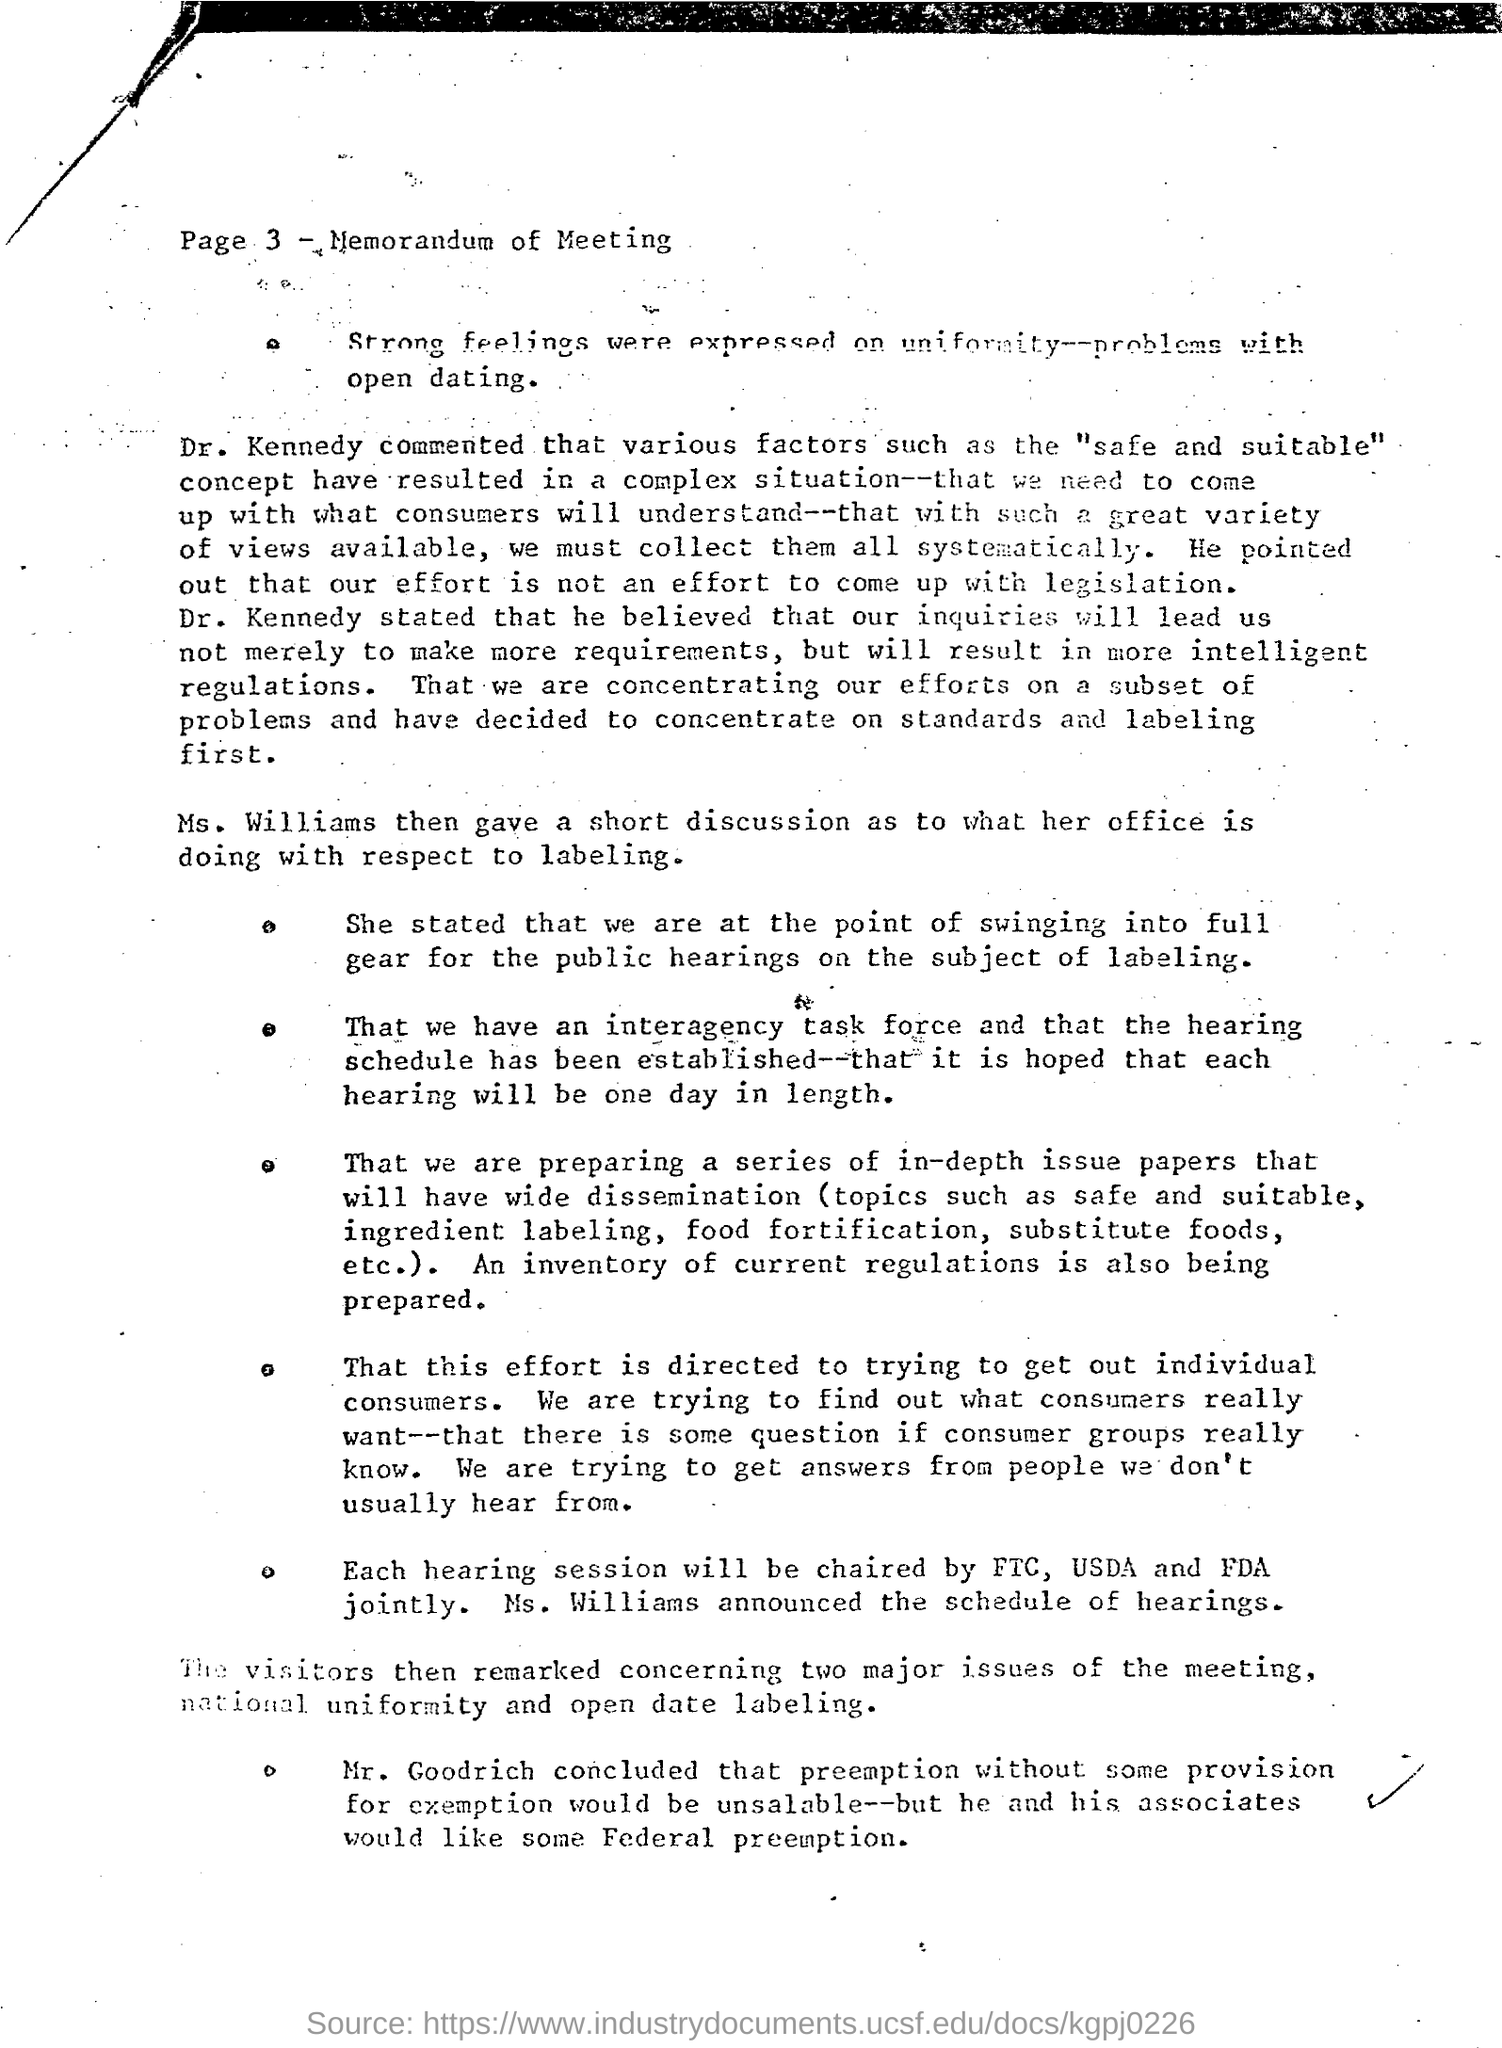What is page 3 heading
Provide a succinct answer. Memorandum of Meeting. Who gave a short discussion as to what her office is doing with respect to labeling?
Keep it short and to the point. Ms. Williams. It is hoped that each hearing will be in what length
Your answer should be very brief. One day. Who announced the schedule of hearings
Ensure brevity in your answer.  Ms williams. 